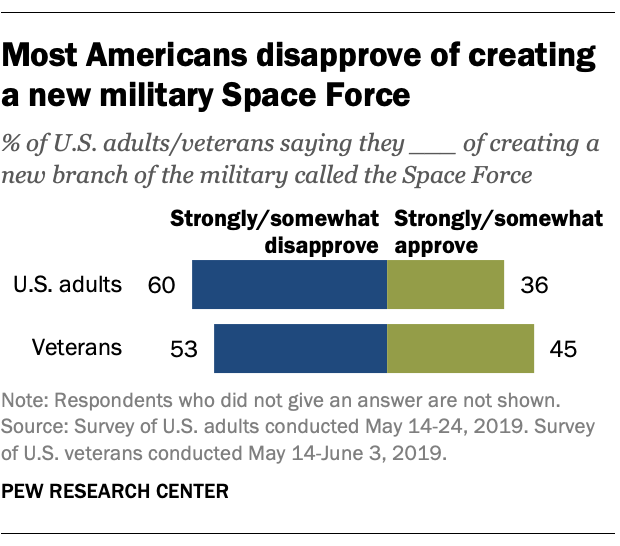Give some essential details in this illustration. The average of green bars is less than the average of blue bars. Six in ten U.S. adults strongly disapprove of the job performance of the President. 